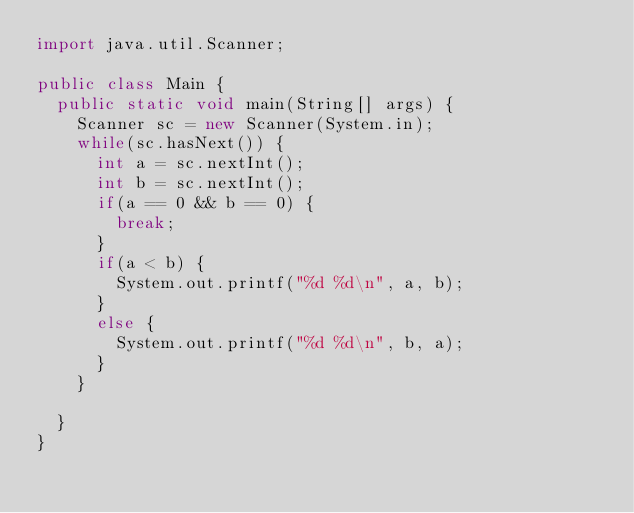Convert code to text. <code><loc_0><loc_0><loc_500><loc_500><_Java_>import java.util.Scanner;

public class Main {
	public static void main(String[] args) {
		Scanner sc = new Scanner(System.in);
		while(sc.hasNext()) {
			int a = sc.nextInt();
			int b = sc.nextInt();
			if(a == 0 && b == 0) {
				break;
			}
			if(a < b) {
				System.out.printf("%d %d\n", a, b);
			}
			else {
				System.out.printf("%d %d\n", b, a);
			}
		}
		
	}
}

</code> 